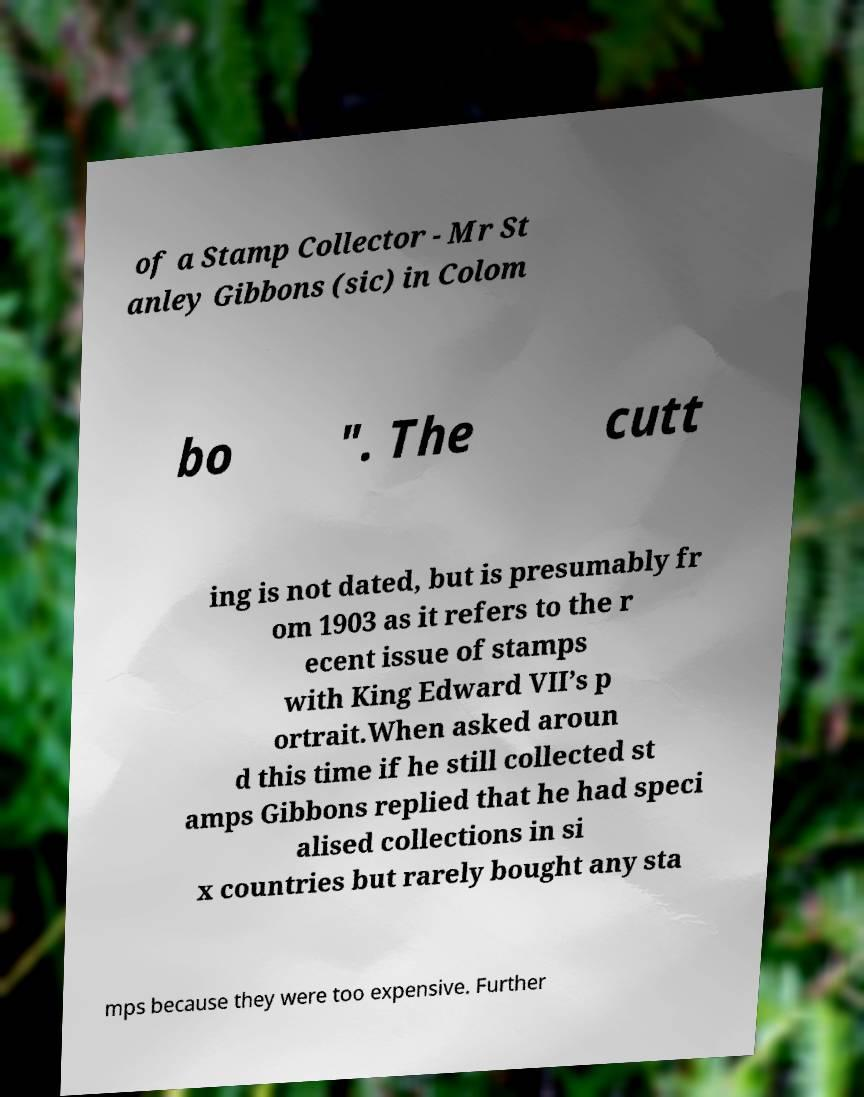Could you assist in decoding the text presented in this image and type it out clearly? of a Stamp Collector - Mr St anley Gibbons (sic) in Colom bo ". The cutt ing is not dated, but is presumably fr om 1903 as it refers to the r ecent issue of stamps with King Edward VII’s p ortrait.When asked aroun d this time if he still collected st amps Gibbons replied that he had speci alised collections in si x countries but rarely bought any sta mps because they were too expensive. Further 